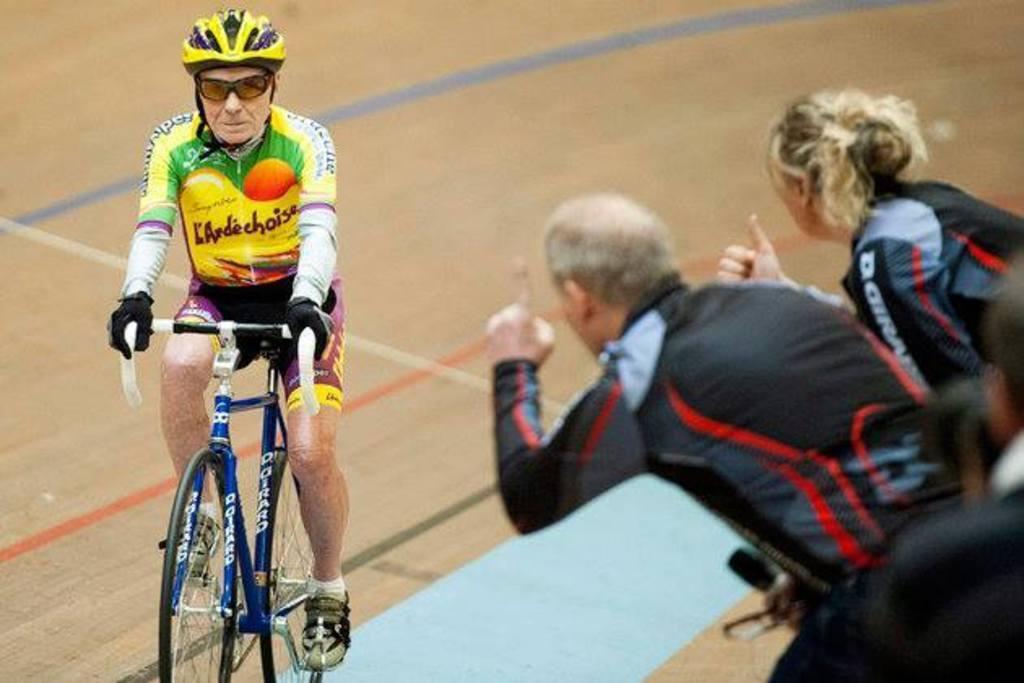Could you give a brief overview of what you see in this image? In this picture we can see three people and in front of them we can see a man wore a helmet, goggles, gloves, shoes and riding a bicycle on the ground. 